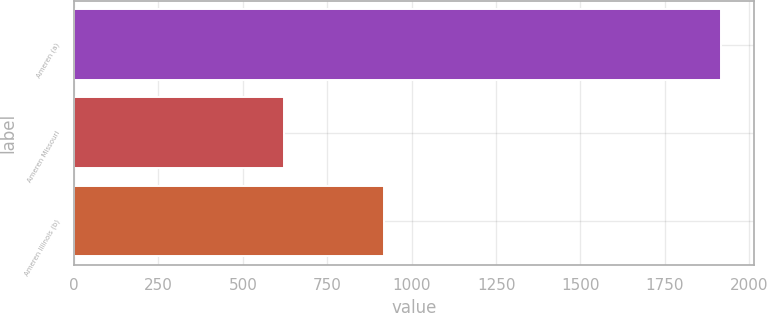<chart> <loc_0><loc_0><loc_500><loc_500><bar_chart><fcel>Ameren (a)<fcel>Ameren Missouri<fcel>Ameren Illinois (b)<nl><fcel>1917<fcel>622<fcel>918<nl></chart> 